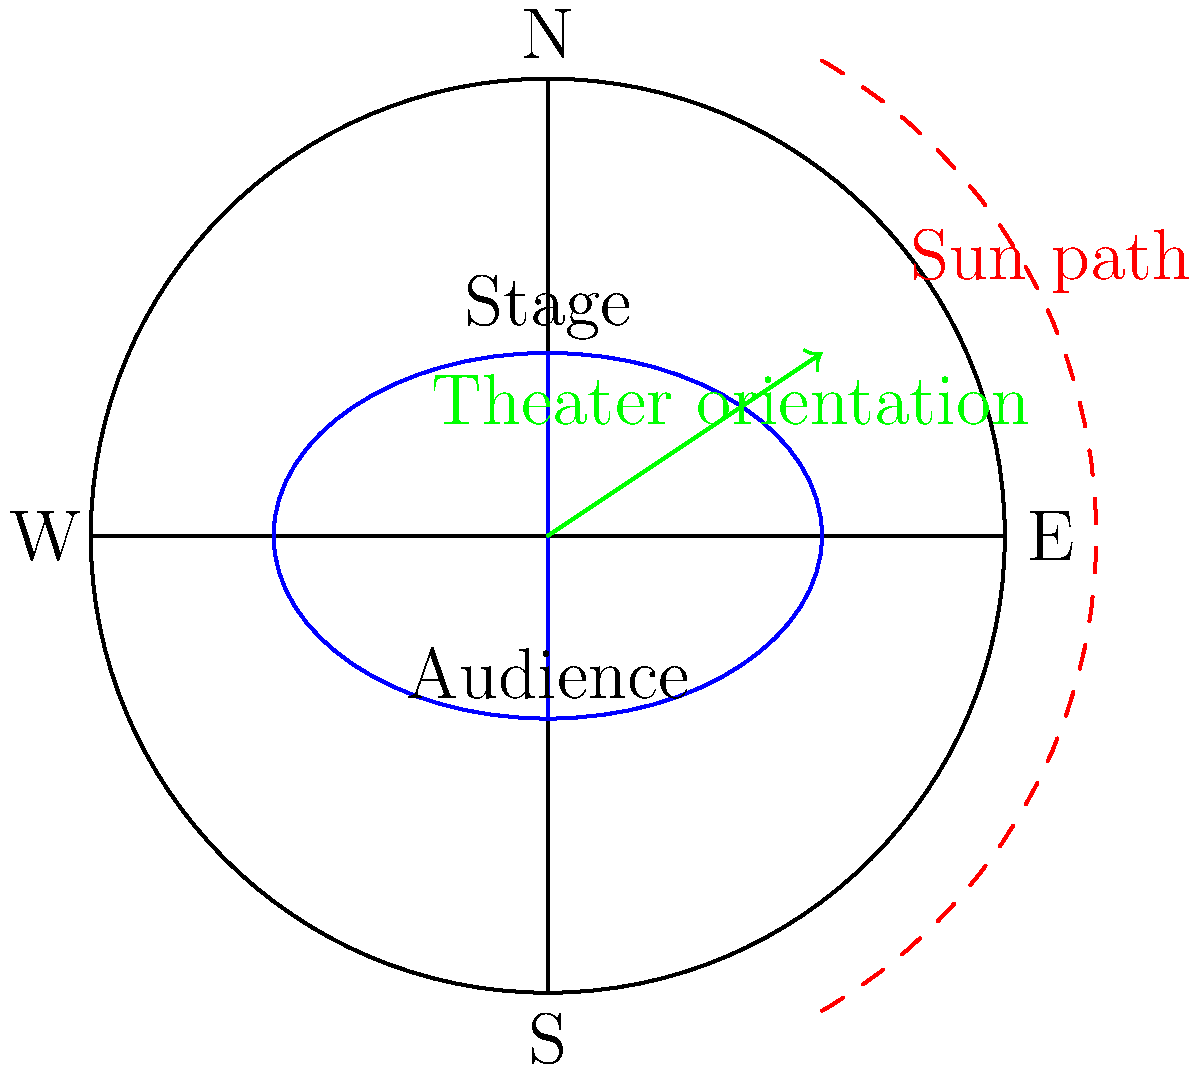In the design of Elizabethan theaters, what astronomical consideration was often taken into account when determining the orientation of the stage, and how did this relate to the actors' visibility during performances? 1. Elizabethan theaters were often designed with astronomical considerations in mind, particularly the path of the sun across the sky.

2. The sun's path in the northern hemisphere moves from east to west, arcing through the southern sky.

3. To take advantage of natural lighting and avoid glare:
   a) The stage was typically positioned on the north side of the theater.
   b) The audience area was situated to the south.

4. This orientation meant that:
   a) The sun would be behind the stage for most of the day.
   b) The actors' faces would be naturally illuminated.
   c) The audience would not have to look into the sun to view the performance.

5. The east-west axis of the theater often aligned with the sun's path, further optimizing lighting conditions throughout the day.

6. This astronomical alignment served practical purposes:
   a) It maximized the use of natural light in an era before artificial lighting.
   b) It enhanced visibility for the audience.
   c) It created favorable lighting conditions for the actors.

7. The orientation also had symbolic significance, potentially aligning with cosmic or religious symbolism popular during the Elizabethan era.

Therefore, the orientation of Elizabethan theaters, with stages typically facing south, was a deliberate design choice based on the sun's path to enhance natural lighting and actor visibility.
Answer: South-facing stage aligned with sun's path for optimal natural lighting and actor visibility 